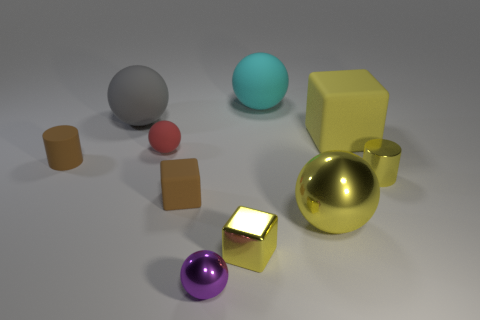Subtract all metallic cubes. How many cubes are left? 2 Subtract 2 cylinders. How many cylinders are left? 0 Subtract all gray cylinders. How many gray blocks are left? 0 Subtract all brown cubes. How many cubes are left? 2 Subtract 0 gray blocks. How many objects are left? 10 Subtract all cylinders. How many objects are left? 8 Subtract all blue cubes. Subtract all red spheres. How many cubes are left? 3 Subtract all rubber cylinders. Subtract all small objects. How many objects are left? 3 Add 1 big matte objects. How many big matte objects are left? 4 Add 2 purple spheres. How many purple spheres exist? 3 